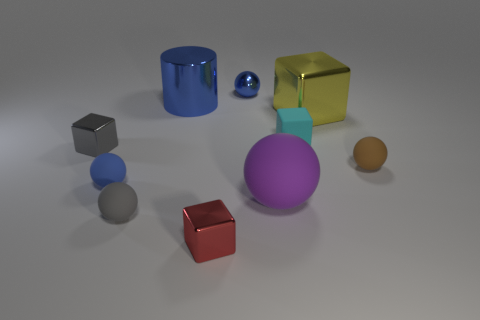Subtract all brown matte spheres. How many spheres are left? 4 Subtract all brown spheres. How many spheres are left? 4 Subtract all cyan balls. Subtract all brown cylinders. How many balls are left? 5 Subtract all blocks. How many objects are left? 6 Subtract 0 gray cylinders. How many objects are left? 10 Subtract all small brown things. Subtract all tiny purple rubber objects. How many objects are left? 9 Add 4 big yellow metallic objects. How many big yellow metallic objects are left? 5 Add 2 cyan cubes. How many cyan cubes exist? 3 